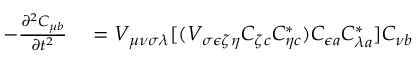<formula> <loc_0><loc_0><loc_500><loc_500>\begin{array} { r l } { - \frac { \partial ^ { 2 } C _ { \mu b } } { \partial t ^ { 2 } } } & = V _ { \mu \nu \sigma \lambda } [ ( V _ { \sigma \epsilon \zeta \eta } C _ { \zeta c } C _ { \eta c } ^ { * } ) C _ { \epsilon a } C _ { \lambda a } ^ { * } ] C _ { \nu b } } \end{array}</formula> 